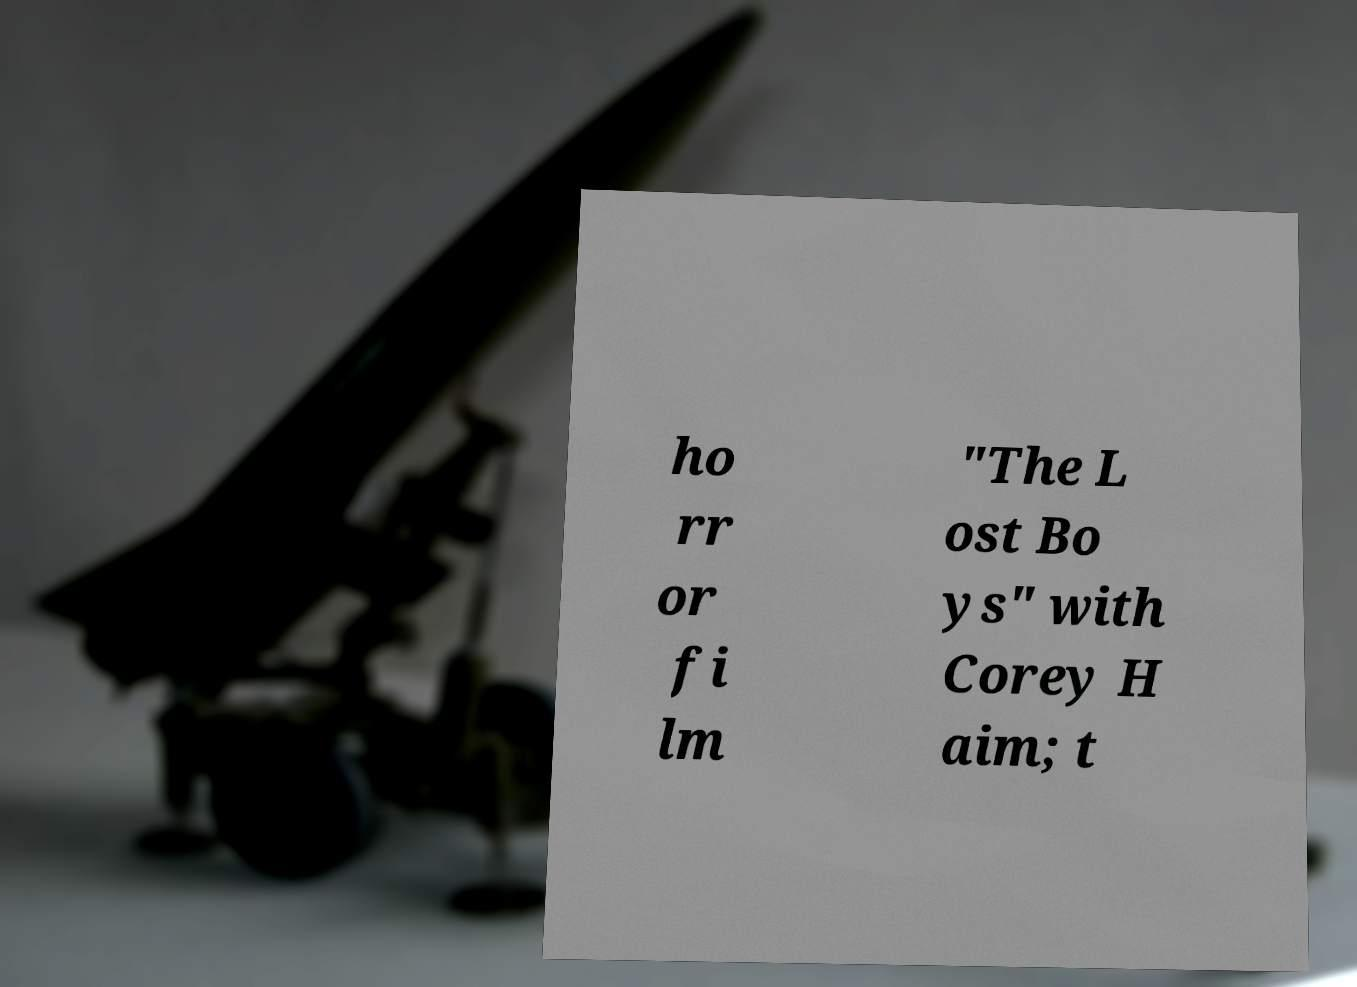I need the written content from this picture converted into text. Can you do that? ho rr or fi lm "The L ost Bo ys" with Corey H aim; t 